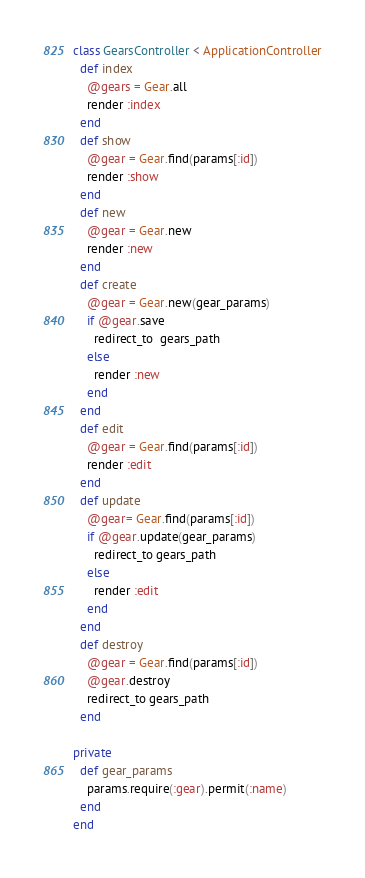<code> <loc_0><loc_0><loc_500><loc_500><_Ruby_>class GearsController < ApplicationController
  def index
    @gears = Gear.all
    render :index
  end
  def show
    @gear = Gear.find(params[:id])
    render :show
  end
  def new
    @gear = Gear.new
    render :new
  end
  def create
    @gear = Gear.new(gear_params)
    if @gear.save
      redirect_to  gears_path
    else
      render :new
    end
  end
  def edit
    @gear = Gear.find(params[:id])
    render :edit
  end
  def update
    @gear= Gear.find(params[:id])
    if @gear.update(gear_params)
      redirect_to gears_path
    else
      render :edit
    end
  end
  def destroy
    @gear = Gear.find(params[:id])
    @gear.destroy
    redirect_to gears_path
  end

private
  def gear_params
    params.require(:gear).permit(:name)
  end
end
</code> 